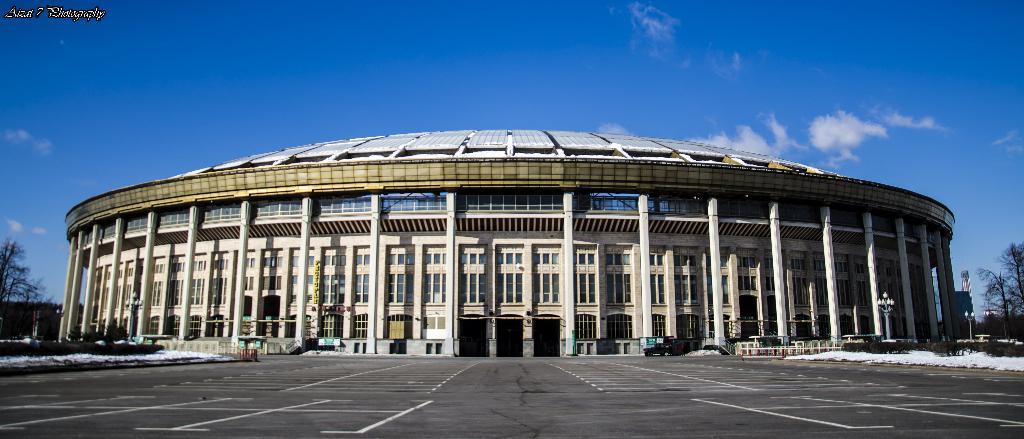How would you summarize this image in a sentence or two? In this picture we can see snow, vehicle on the road, building, pillars, boards, trees, banner attached to a pole and objects. In the background of the image we can see the sky. In the top left side of the image we can see text. 